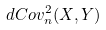Convert formula to latex. <formula><loc_0><loc_0><loc_500><loc_500>d C o v _ { n } ^ { 2 } ( X , Y )</formula> 